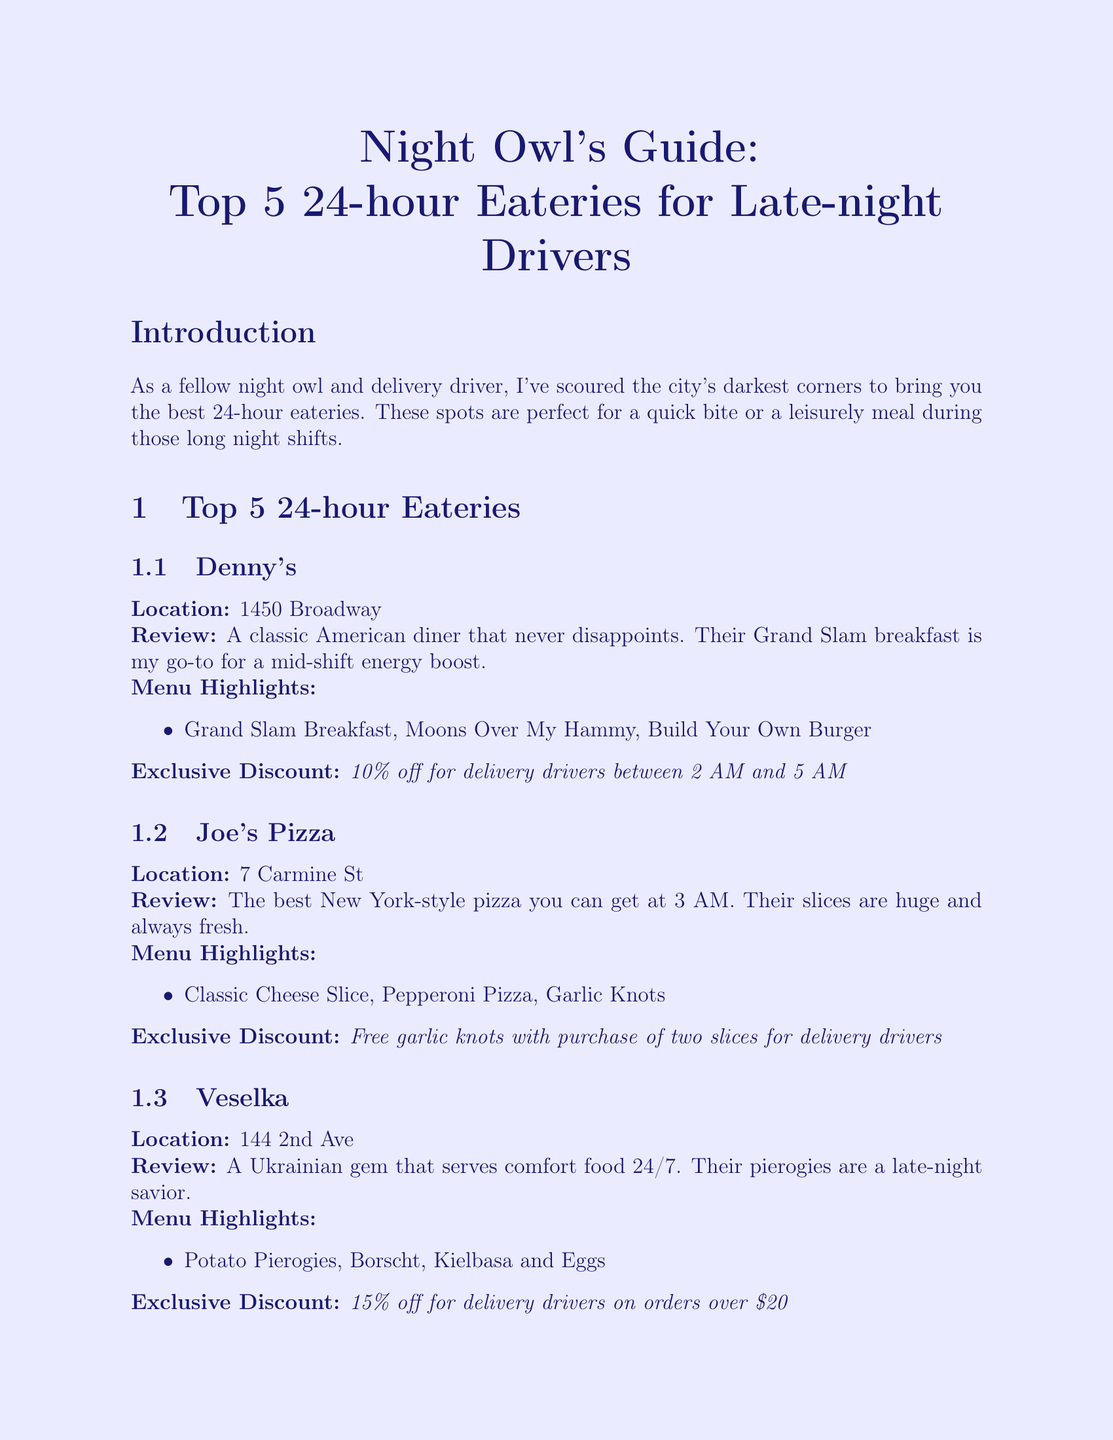What is the first eatery listed? The first eatery listed in the document is Denny's.
Answer: Denny's What discount do delivery drivers get at Veselka? The discount for delivery drivers at Veselka is 15% off on orders over $20.
Answer: 15% off for delivery drivers on orders over $20 How many eateries are listed in total? The document lists a total of 5 eateries.
Answer: 5 What is the location of Joe's Pizza? The location of Joe's Pizza is 7 Carmine St.
Answer: 7 Carmine St Which eatery offers free coffee refills? The eatery that offers free coffee refills is L.A. Café.
Answer: L.A. Café What is the main menu highlight at Denny's? The main menu highlight at Denny's is the Grand Slam Breakfast.
Answer: Grand Slam Breakfast What is the review star rating for Waffle House? The document doesn't provide a star rating for Waffle House.
Answer: Not provided What is the author's experience in years? The author's experience, as stated in the document, is 5 years.
Answer: 5 years What is the theme of the newsletter? The theme of the newsletter is focused on 24-hour eateries for late-night drivers.
Answer: 24-hour eateries for late-night drivers 